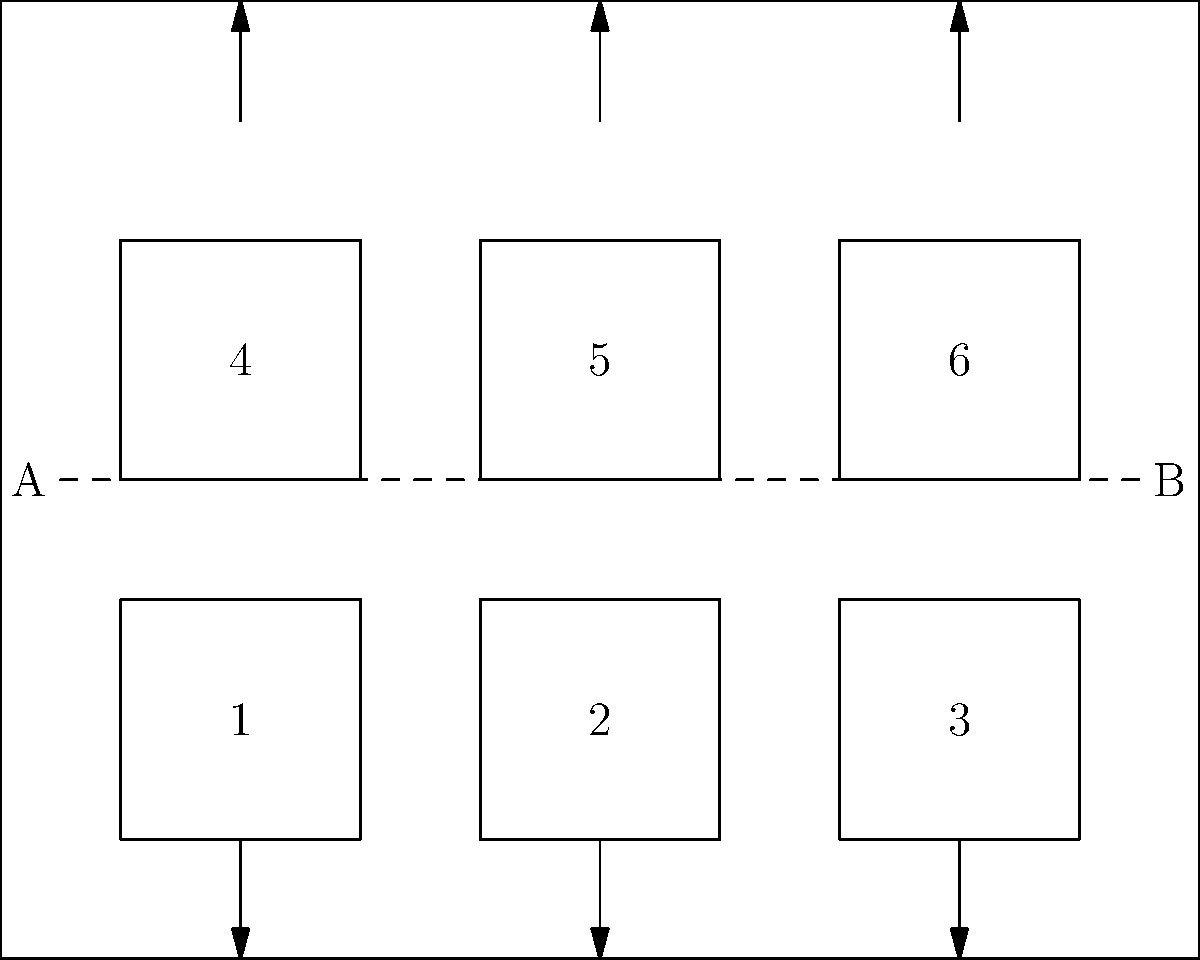Given the trade show floor plan above with two power sources (A and B) and six booths (1-6), what is the minimum number of power distribution units (PDUs) needed to ensure each booth has access to power, assuming each PDU can support up to 3 booths? To determine the minimum number of PDUs needed, we need to follow these steps:

1. Identify the number of booths: There are 6 booths in total.

2. Understand the PDU capacity: Each PDU can support up to 3 booths.

3. Consider the layout:
   - Booths 1, 2, and 3 are in one row
   - Booths 4, 5, and 6 are in another row

4. Optimize PDU placement:
   - We can use one PDU to power booths 1, 2, and 3
   - We can use another PDU to power booths 4, 5, and 6

5. Calculate the total:
   - We need 2 PDUs to efficiently power all 6 booths

6. Verify:
   - 2 PDUs × 3 booths per PDU = 6 booths (which matches our total)

Therefore, the minimum number of PDUs needed is 2, which allows for efficient power distribution to all booths while minimizing equipment usage.
Answer: 2 PDUs 